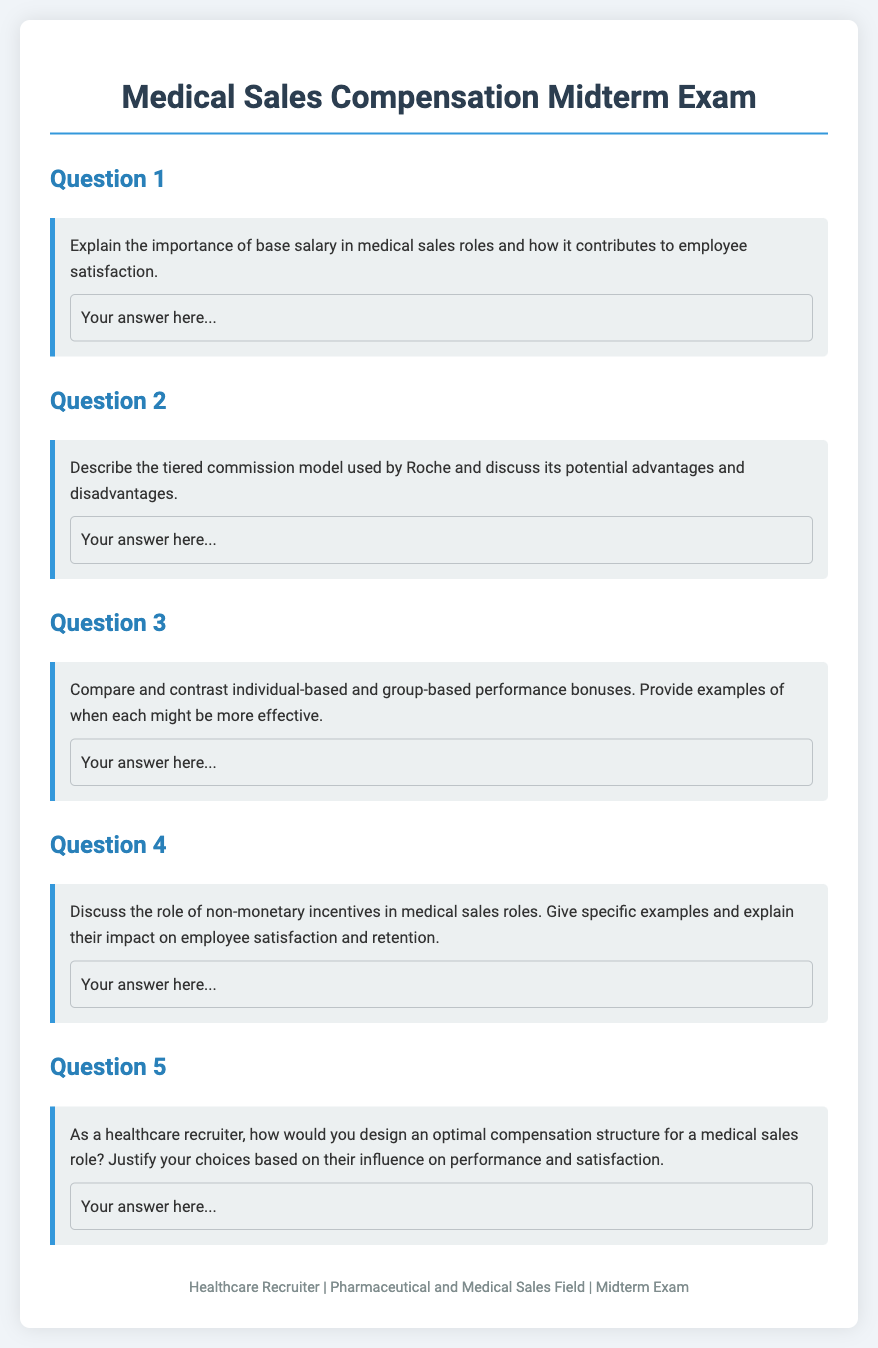What is the title of the document? The title of the document is presented prominently at the top of the page, indicating the focus of the content.
Answer: Medical Sales Compensation Midterm Exam What is the primary role discussed in the document? The document revolves around a specific role within the healthcare sector, which is highlighted in the context of compensation.
Answer: Medical sales roles What is the first question in the exam about? The first question addresses a key component of compensation that influences employee satisfaction in medical sales.
Answer: Importance of base salary What type of commission model is mentioned in the second question? The second question references a specific model used by a well-known pharmaceutical company, which is relevant to the structure of incentives.
Answer: Tiered commission model What does the fourth question discuss? The fourth question explores an aspect of motivation that is not financial, considering its implications for workforce morale and stability.
Answer: Non-monetary incentives How many questions are included in the exam? The total number of questions can be determined by counting the headings designated as question sections throughout the document.
Answer: Five 